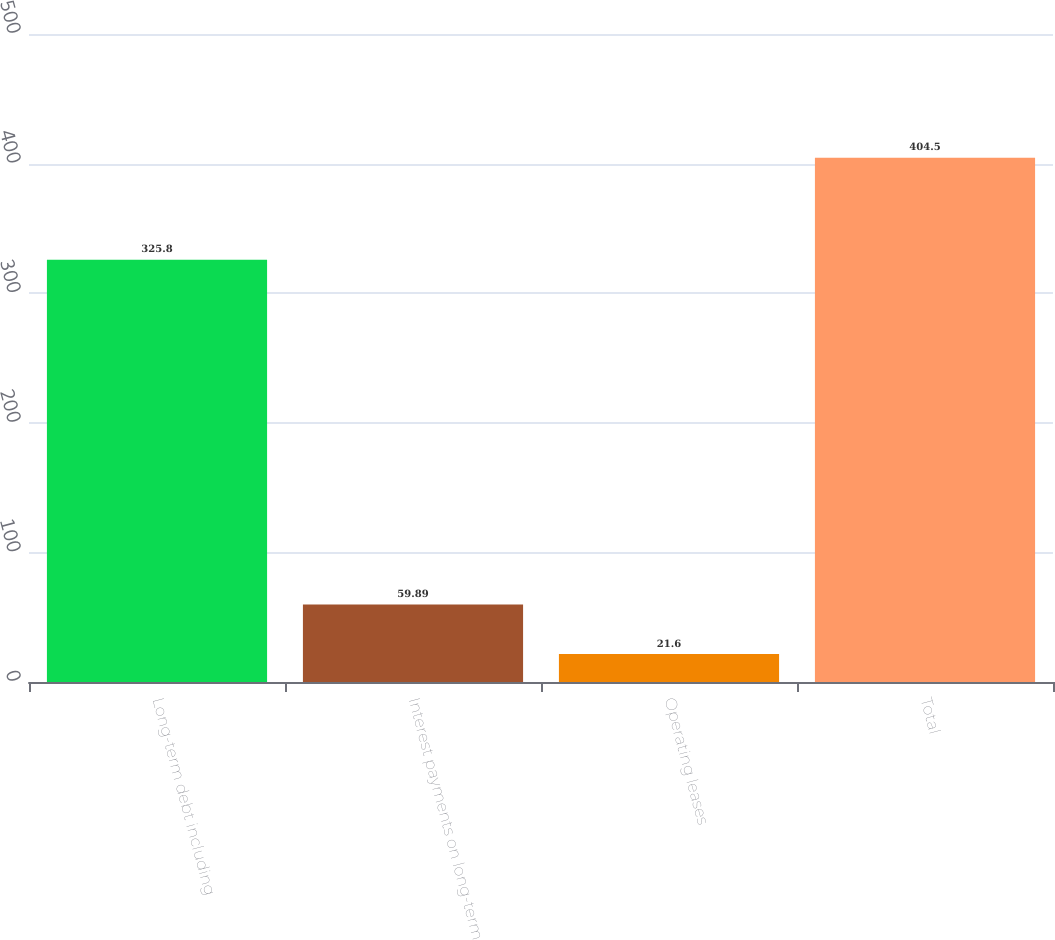Convert chart. <chart><loc_0><loc_0><loc_500><loc_500><bar_chart><fcel>Long-term debt including<fcel>Interest payments on long-term<fcel>Operating leases<fcel>Total<nl><fcel>325.8<fcel>59.89<fcel>21.6<fcel>404.5<nl></chart> 